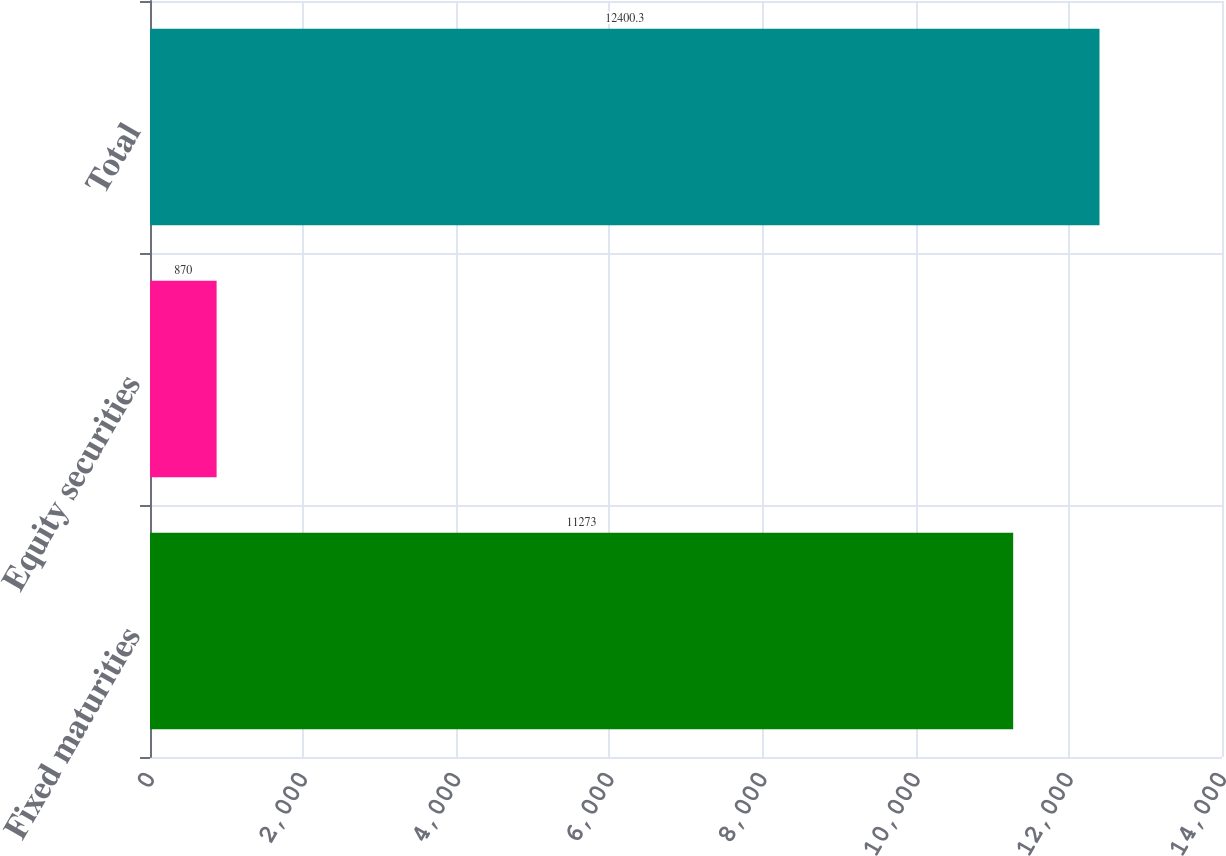Convert chart to OTSL. <chart><loc_0><loc_0><loc_500><loc_500><bar_chart><fcel>Fixed maturities<fcel>Equity securities<fcel>Total<nl><fcel>11273<fcel>870<fcel>12400.3<nl></chart> 